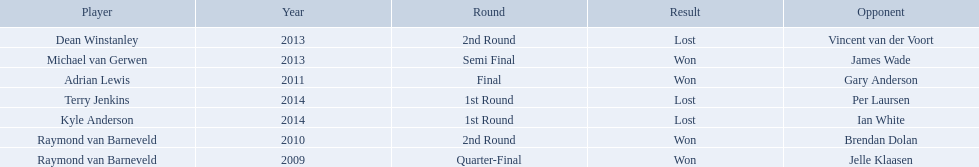Who were all the players? Raymond van Barneveld, Raymond van Barneveld, Adrian Lewis, Dean Winstanley, Michael van Gerwen, Terry Jenkins, Kyle Anderson. Which of these played in 2014? Terry Jenkins, Kyle Anderson. Who were their opponents? Per Laursen, Ian White. Which of these beat terry jenkins? Per Laursen. 